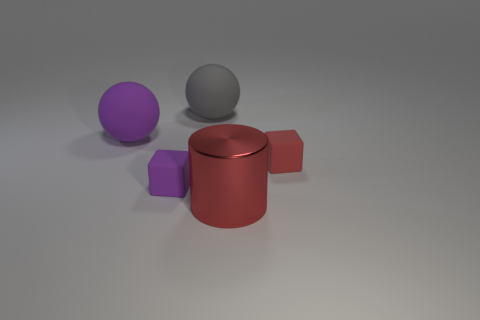Add 5 tiny red metal things. How many objects exist? 10 Subtract all cylinders. How many objects are left? 4 Subtract 1 cubes. How many cubes are left? 1 Add 1 tiny purple things. How many tiny purple things are left? 2 Add 1 spheres. How many spheres exist? 3 Subtract 1 gray balls. How many objects are left? 4 Subtract all yellow balls. Subtract all yellow cubes. How many balls are left? 2 Subtract all large gray rubber blocks. Subtract all gray balls. How many objects are left? 4 